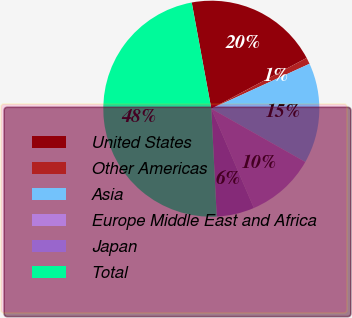<chart> <loc_0><loc_0><loc_500><loc_500><pie_chart><fcel>United States<fcel>Other Americas<fcel>Asia<fcel>Europe Middle East and Africa<fcel>Japan<fcel>Total<nl><fcel>20.11%<fcel>0.96%<fcel>15.04%<fcel>10.34%<fcel>5.65%<fcel>47.89%<nl></chart> 